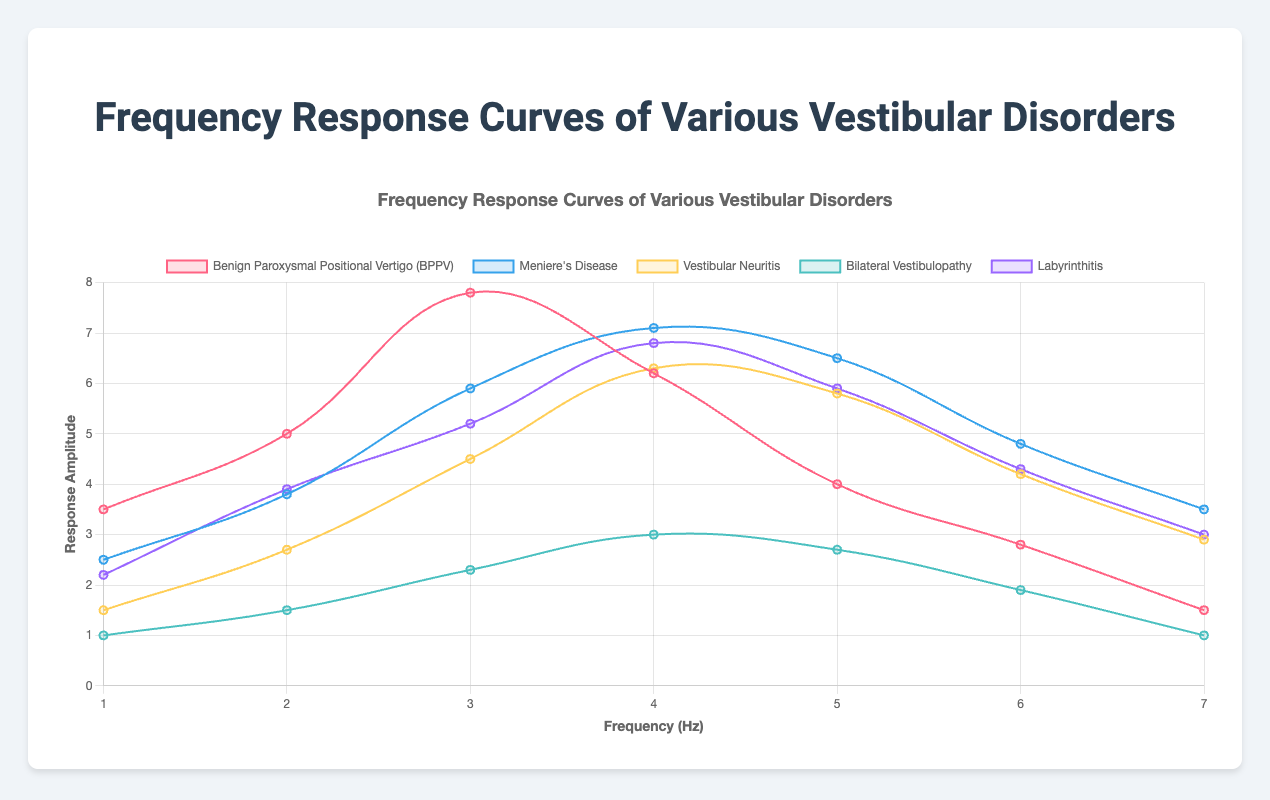What is the frequency at which Benign Paroxysmal Positional Vertigo (BPPV) has the highest response amplitude? The BPPV data shows response amplitudes at different frequencies. The highest amplitude is 7.8 at frequency 3.
Answer: 3 Which disorder exhibits the highest response amplitude overall, and at what frequency does this occur? By comparing all data points across all disorders, the highest amplitude is 7.8, which occurs in BPPV at frequency 3.
Answer: BPPV at frequency 3 How does the response amplitude of Meniere's Disease at frequency 4 compare to that of Vestibular Neuritis at the same frequency? At frequency 4, the response amplitude for Meniere's Disease is 7.1, while for Vestibular Neuritis, it is 6.3. Meniere's Disease has a higher response amplitude.
Answer: Meniere's Disease is higher What is the difference between the highest and lowest response amplitudes for Labyrinthitis? The highest amplitude for Labyrinthitis is 6.8 at frequency 4 and the lowest is 2.2 at frequency 1. The difference is 6.8 - 2.2 = 4.6.
Answer: 4.6 At which frequency does Bilateral Vestibulopathy show the same response amplitude as the lowest response seen in Meniere's Disease, and what is that amplitude? The lowest response amplitude in Meniere's Disease is 2.5 at frequency 1. The same amplitude for Bilateral Vestibulopathy occurs at frequency 1.
Answer: 1, 2.5 Compare the patterns of response amplitude changes between the initial (frequency 1) and final (frequency 7) points for BPPV and Labyrinthitis. What can you conclude? For BPPV, the response starts at 3.5 and decreases to 1.5. For Labyrinthitis, it starts at 2.2 and decreases to 3. The patterns show a general decline over the frequencies for both but at different rates.
Answer: Both disorders show a decline What is the average response amplitude for Vestibular Neuritis across all the frequencies? Sum the amplitudes for Vestibular Neuritis: 1.5 + 2.7 + 4.5 + 6.3 + 5.8 + 4.2 + 2.9 = 27.9. Divide by the number of frequencies (7). The average is 27.9 / 7 ≈ 3.99.
Answer: 3.99 Which disorder has the smallest variation in response amplitudes across all the frequencies, and how did you determine it? Calculate the range (max - min) for each disorder. Bilateral Vestibulopathy has the smallest range: 3.0 - 1.0 = 2.0.
Answer: Bilateral Vestibulopathy 